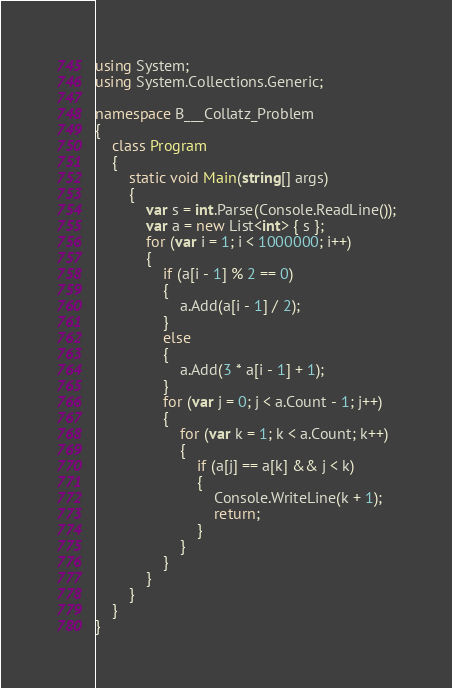<code> <loc_0><loc_0><loc_500><loc_500><_C#_>using System;
using System.Collections.Generic;

namespace B___Collatz_Problem
{
    class Program
    {
        static void Main(string[] args)
        {
            var s = int.Parse(Console.ReadLine());
            var a = new List<int> { s };
            for (var i = 1; i < 1000000; i++)
            {
                if (a[i - 1] % 2 == 0)
                {
                    a.Add(a[i - 1] / 2);
                }
                else
                {
                    a.Add(3 * a[i - 1] + 1);
                }
                for (var j = 0; j < a.Count - 1; j++)
                {
                    for (var k = 1; k < a.Count; k++)
                    {
                        if (a[j] == a[k] && j < k)
                        {
                            Console.WriteLine(k + 1);
                            return;
                        }
                    }
                }
            }
        }
    }
}</code> 